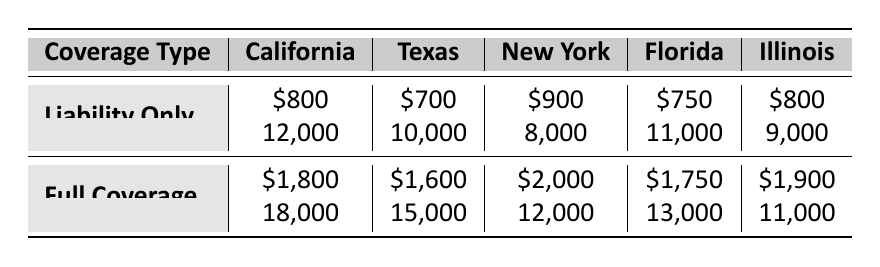What is the average cost of Liability Only coverage in California? According to the table, the average cost for Liability Only coverage in California is $800.
Answer: 800 How many families have Full Coverage in Texas? The table shows that there are 15,000 families with Full Coverage in Texas.
Answer: 15000 Which state has the highest average cost for Full Coverage? The table indicates that New York has the highest average cost for Full Coverage at $2,000, compared to other states which have lower costs.
Answer: New York What is the total number of families for Liability Only coverage across all states? To find the total, sum the families for Liability Only coverage in each state: 12,000 (California) + 10,000 (Texas) + 8,000 (New York) + 11,000 (Florida) + 9,000 (Illinois) = 60,000.
Answer: 60000 Is the average cost of Full Coverage in Florida lower than that in Illinois? The average cost for Full Coverage in Florida is $1,750, while in Illinois it's $1,900, which makes Florida's cost lower.
Answer: Yes What is the average number of families with Full Coverage across all states? First, sum the families with Full Coverage: 18,000 (California) + 15,000 (Texas) + 12,000 (New York) + 13,000 (Florida) + 11,000 (Illinois) = 69,000. Then, divide by the 5 states: 69,000 / 5 = 13,800.
Answer: 13800 Does the average cost of Liability Only coverage in Texas exceed that in California? The average cost of Liability Only in Texas is $700, while in California it is $800, so Texas does not exceed California's cost.
Answer: No Which state has the lowest average cost for Liability Only coverage? The table shows that Texas has the lowest average cost for Liability Only coverage at $700, which is lower than all other states listed.
Answer: Texas 